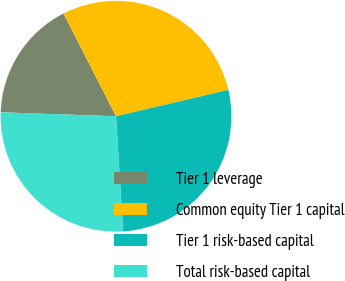Convert chart. <chart><loc_0><loc_0><loc_500><loc_500><pie_chart><fcel>Tier 1 leverage<fcel>Common equity Tier 1 capital<fcel>Tier 1 risk-based capital<fcel>Total risk-based capital<nl><fcel>16.93%<fcel>28.86%<fcel>27.69%<fcel>26.52%<nl></chart> 